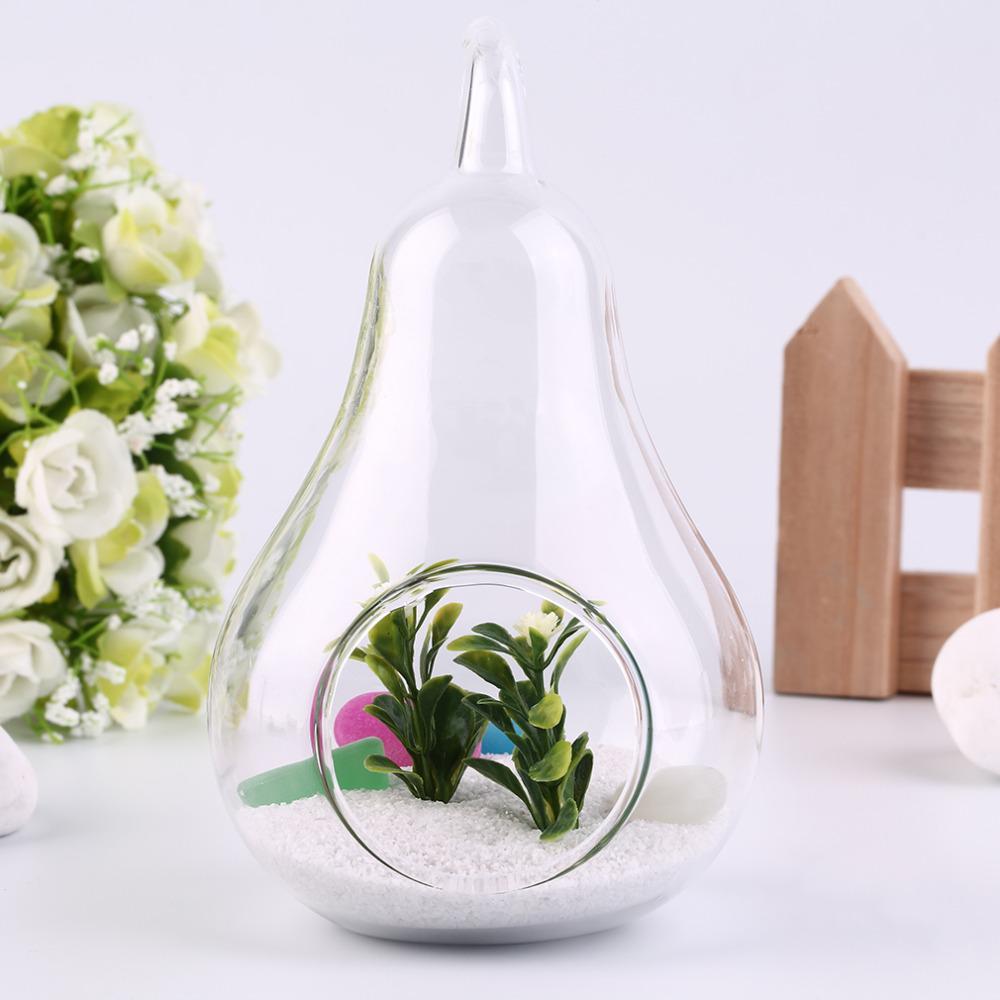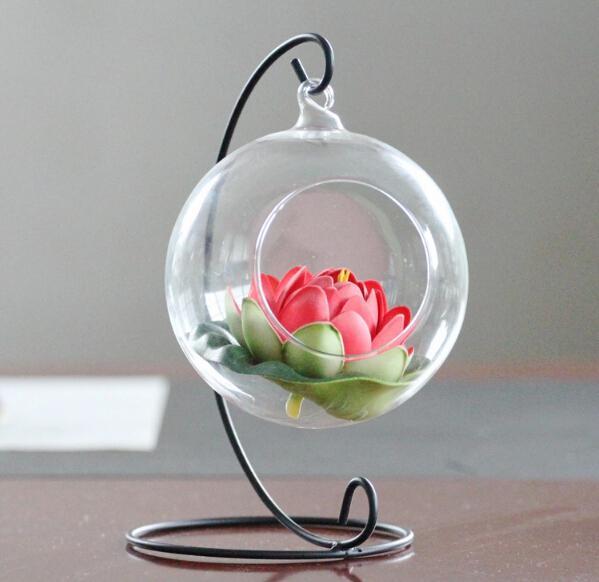The first image is the image on the left, the second image is the image on the right. Assess this claim about the two images: "A single terrarium shaped like a pear sits on a surface in the image on the left.". Correct or not? Answer yes or no. Yes. The first image is the image on the left, the second image is the image on the right. Considering the images on both sides, is "Each image contains side-by-side terrariums in fruit shapes that rest on a surface, and the combined images include at least two pear shapes and one apple shape." valid? Answer yes or no. No. 